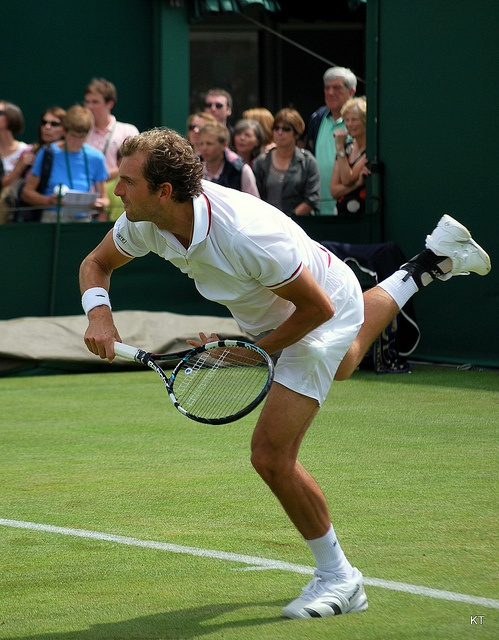Describe the objects in this image and their specific colors. I can see people in black, white, maroon, and darkgray tones, tennis racket in black, olive, and gray tones, people in black, gray, and blue tones, people in black, gray, maroon, and brown tones, and people in black, teal, gray, and maroon tones in this image. 